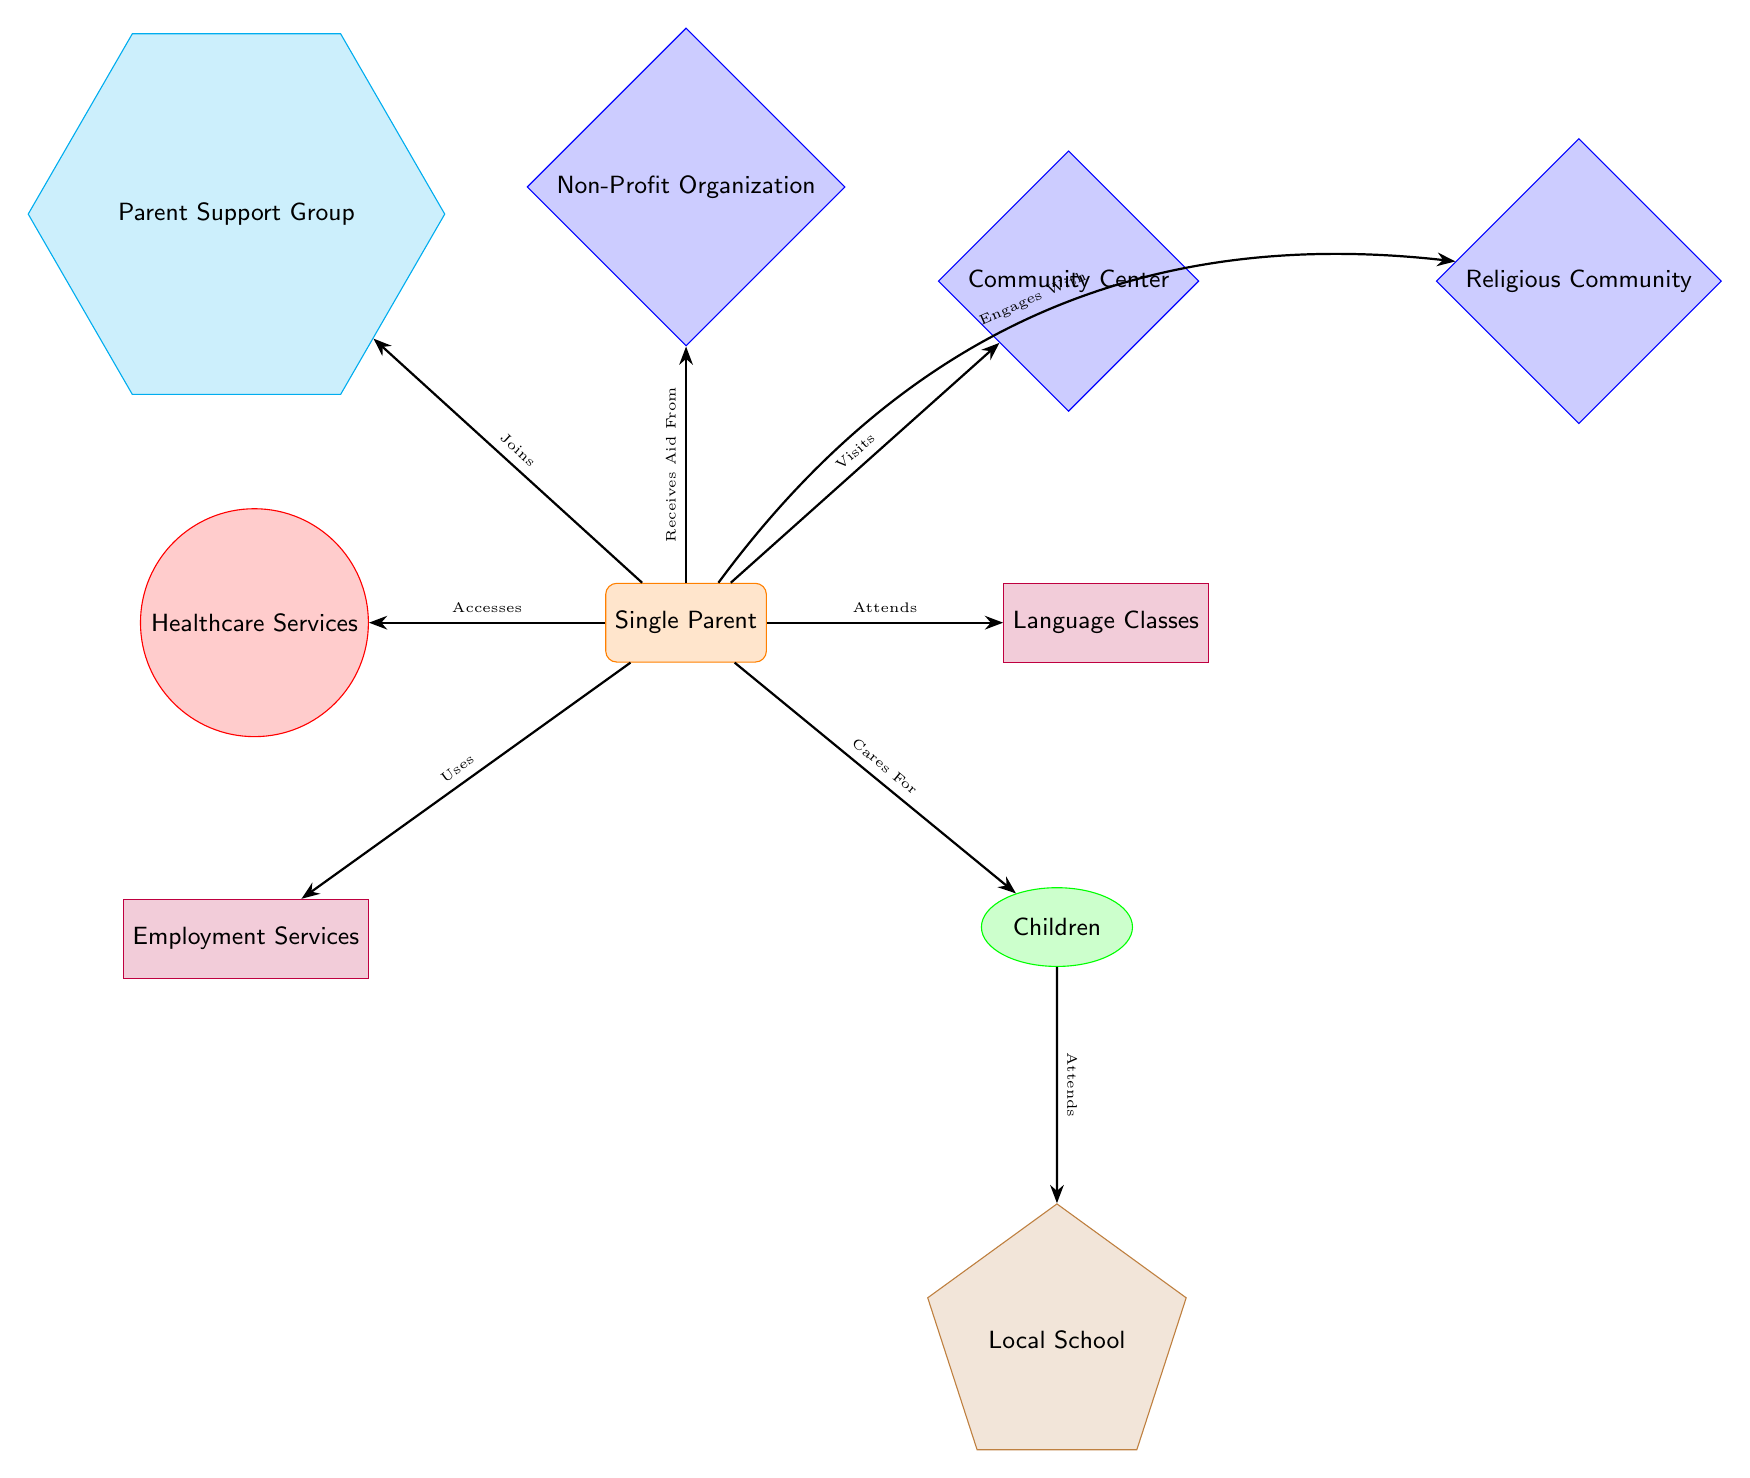What is the main figure represented in the diagram? The main figure represented in the diagram is the single parent, who is illustrated as a central node connected to various resources and services.
Answer: Single Parent How many nodes are connected to the single parent? The single parent is connected to six nodes, representing their children, community center, language classes, healthcare services, parent support group, and non-profit organization.
Answer: Six Which service is used by the single parent to seek employment? The service used by the single parent for employment-related aid is labeled as Employment Services.
Answer: Employment Services What type of resource is the community center classified as? The community center is classified as a resource node, specifically represented as a diamond shape in the diagram.
Answer: Resource How do children obtain education according to the diagram? Children receive education by attending the Local School, which is linked directly to them in the diagram.
Answer: Attends What type of support group does the single parent engage with? The single parent engages with a Parent Support Group, as indicated by the connection to that node in the diagram.
Answer: Parent Support Group Which service does the diagram indicate can provide healthcare? The diagram indicates that Healthcare Services provide healthcare for the single parent, as shown by the directed edge connecting them.
Answer: Healthcare Services What type of community support is represented on the right side of the community center? The type of community support represented on the right side of the community center is a Religious Community, which is directly linked to the community center node.
Answer: Religious Community What action does the single parent take regarding non-profit help? The action taken by the single parent regarding non-profit help is receiving aid from the Non-Profit Organization, as depicted by the directed edge.
Answer: Receives Aid From 